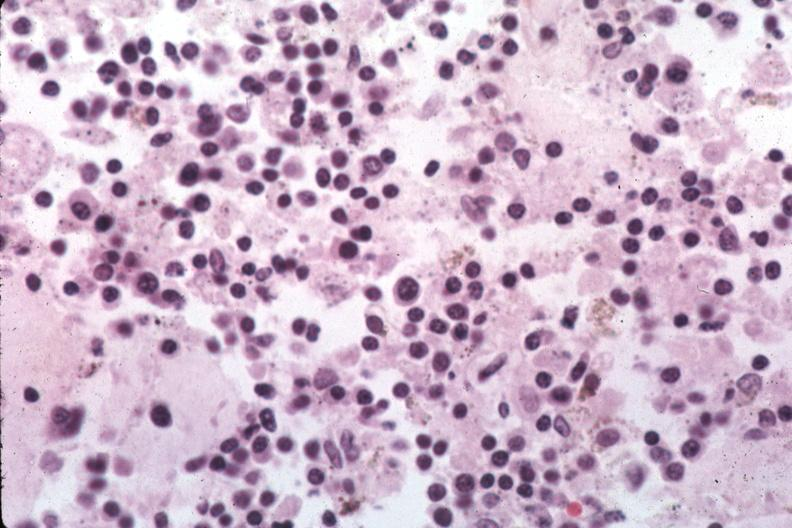s bone marrow present?
Answer the question using a single word or phrase. Yes 